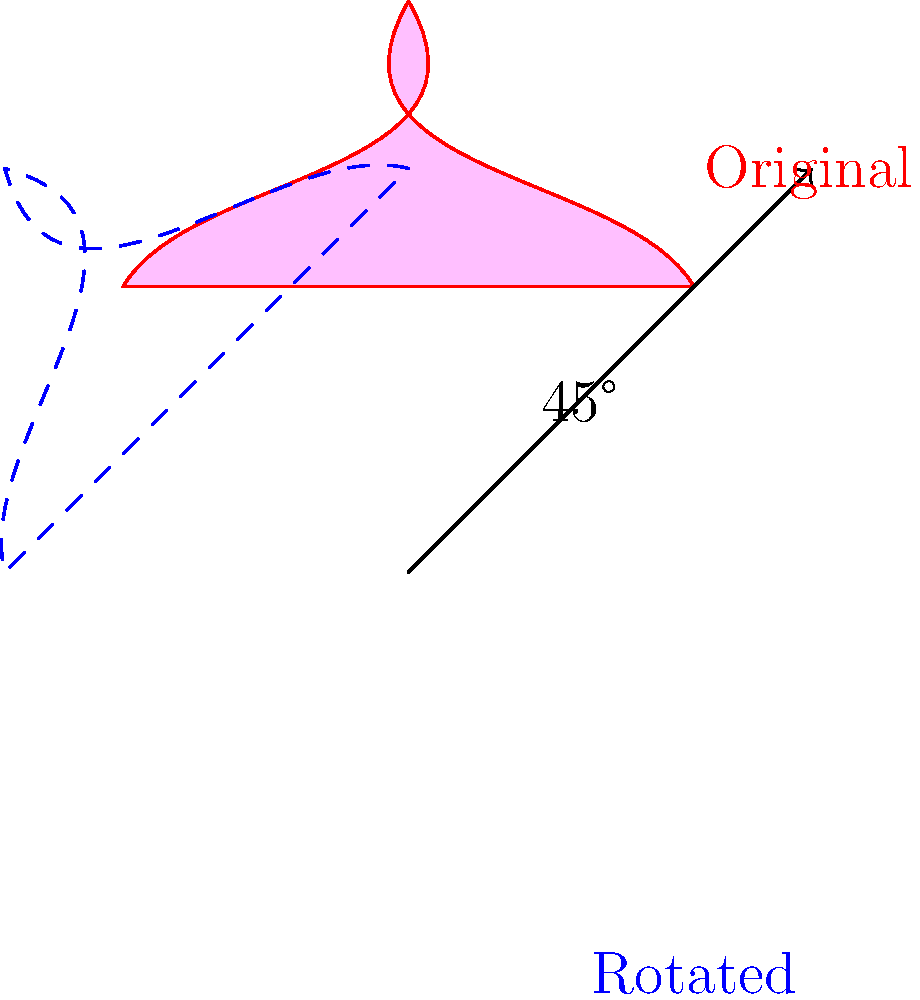For your heart-shaped seating arrangement, you want to rotate it to optimize the ocean views. If the original arrangement faces due north and the best views are towards the northeast, by how many degrees should you rotate the seating arrangement clockwise to align with the optimal view? To solve this problem, let's follow these steps:

1. Understand the initial orientation:
   - The original seating arrangement faces due north (0°)

2. Identify the optimal direction:
   - The best views are towards the northeast

3. Recall compass directions:
   - North: 0°
   - Northeast: 45°
   - East: 90°
   - Southeast: 135°
   - South: 180°
   - Southwest: 225°
   - West: 270°
   - Northwest: 315°

4. Calculate the rotation needed:
   - To face northeast from north, we need to rotate 45° clockwise

5. Verify the solution:
   - A 45° clockwise rotation will align the heart-shaped arrangement with the northeast direction, optimizing the ocean views

Therefore, the seating arrangement should be rotated 45° clockwise to achieve the optimal orientation for ocean views.
Answer: 45° 